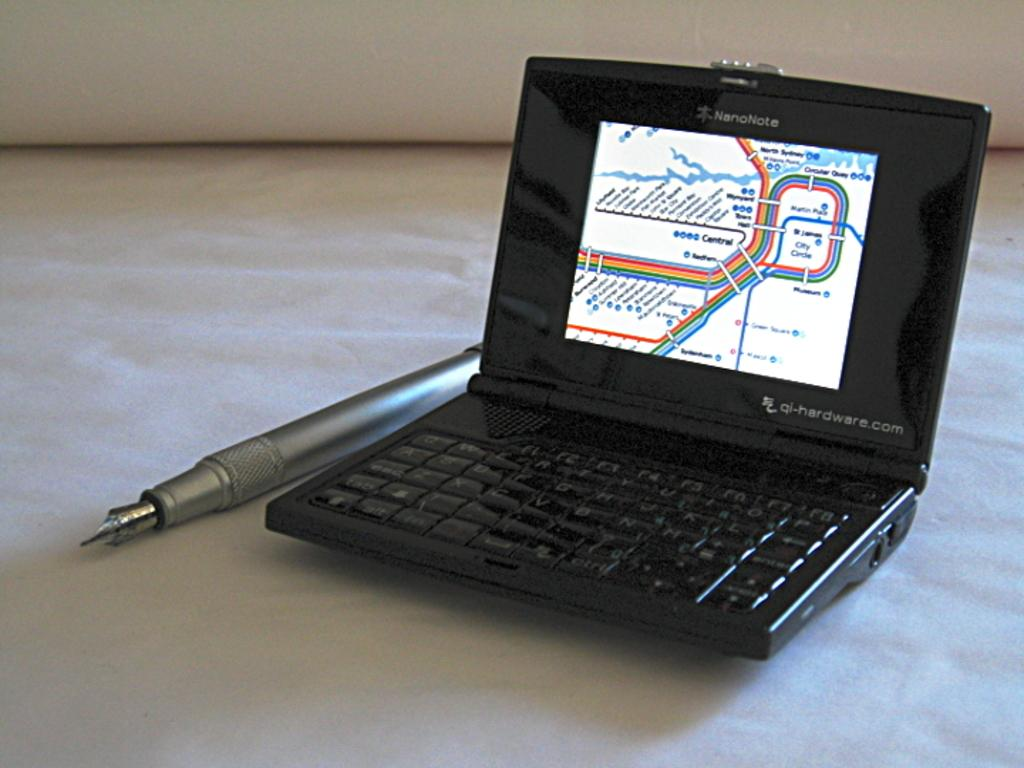What type of electronic device is visible in the image? There is a small black color laptop in the image. What stationery item can be seen in the image? There is an ash color pen in the image. What other object can be seen in the image? There is a white color object in the image. What type of stick is the dog holding in the image? There is no dog present in the image, and therefore no stick can be observed. How does the temper of the laptop affect its performance in the image? The laptop does not have a temper, as it is an inanimate object, and therefore this question is not applicable. 